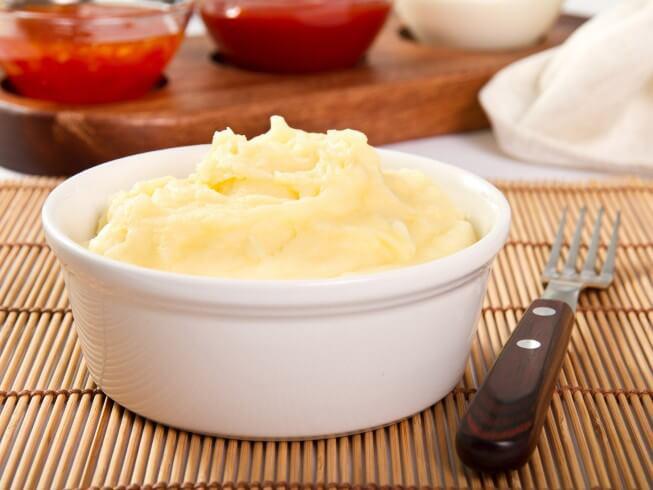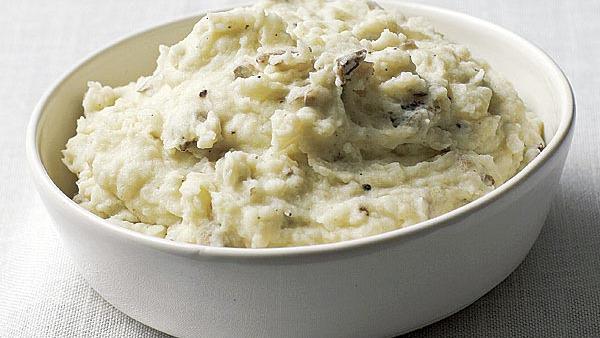The first image is the image on the left, the second image is the image on the right. Given the left and right images, does the statement "An image includes ungarnished mashed potatoes in a round white bowl with a fork near it and a container of something behind it." hold true? Answer yes or no. Yes. The first image is the image on the left, the second image is the image on the right. Given the left and right images, does the statement "The left and right image contains the same number of mash potatoes in a single white bowl." hold true? Answer yes or no. Yes. 